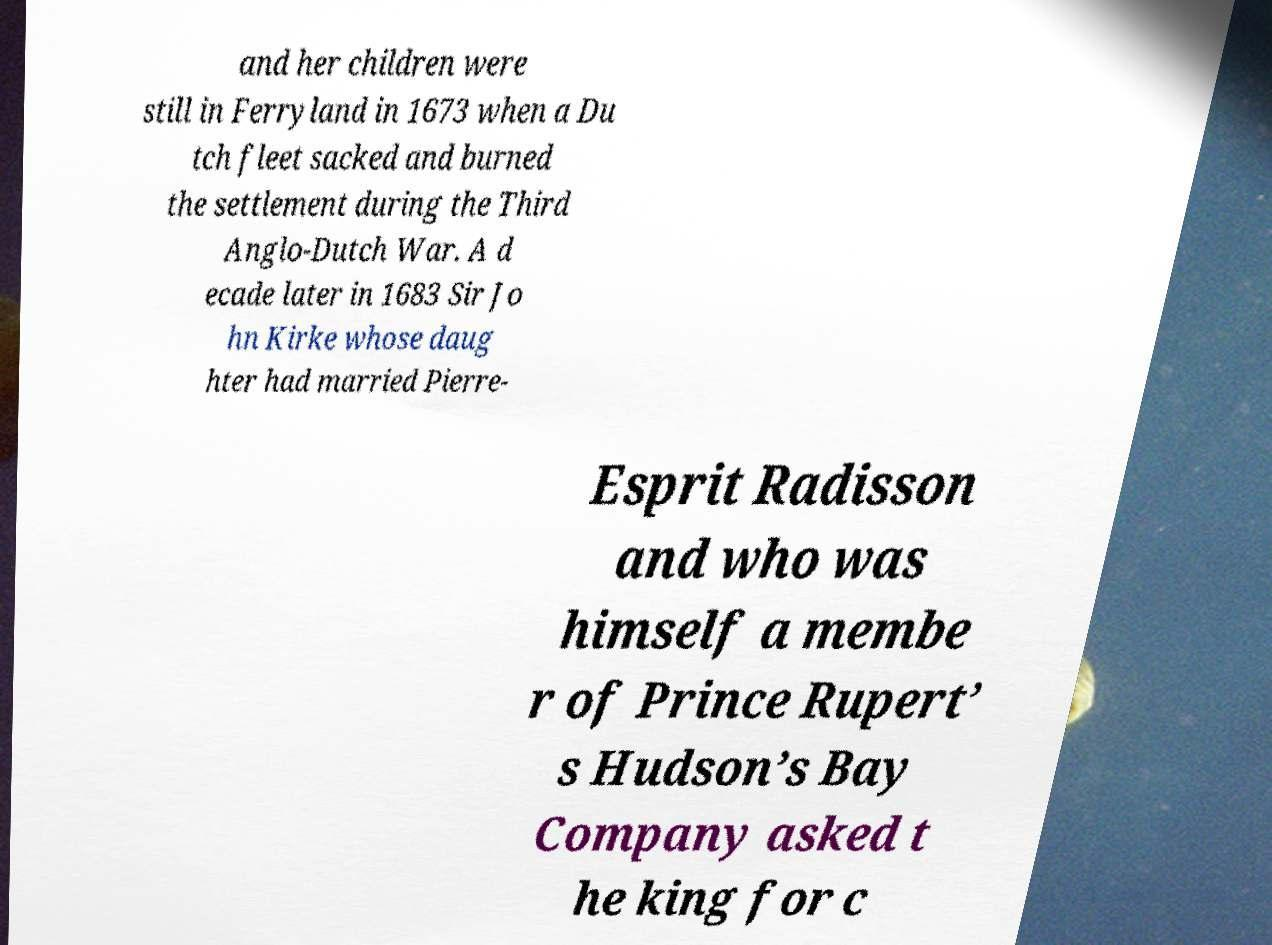Could you assist in decoding the text presented in this image and type it out clearly? and her children were still in Ferryland in 1673 when a Du tch fleet sacked and burned the settlement during the Third Anglo-Dutch War. A d ecade later in 1683 Sir Jo hn Kirke whose daug hter had married Pierre- Esprit Radisson and who was himself a membe r of Prince Rupert’ s Hudson’s Bay Company asked t he king for c 